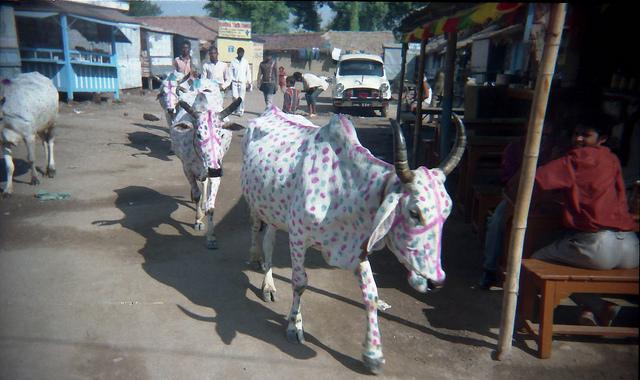Is there more than one animal in this image?
Concise answer only. Yes. What animal is this?
Short answer required. Cow. How come the cows are painted?
Short answer required. Festival. 